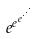<formula> <loc_0><loc_0><loc_500><loc_500>e ^ { e ^ { e ^ { \cdot ^ { \cdot ^ { \cdot } } } } }</formula> 